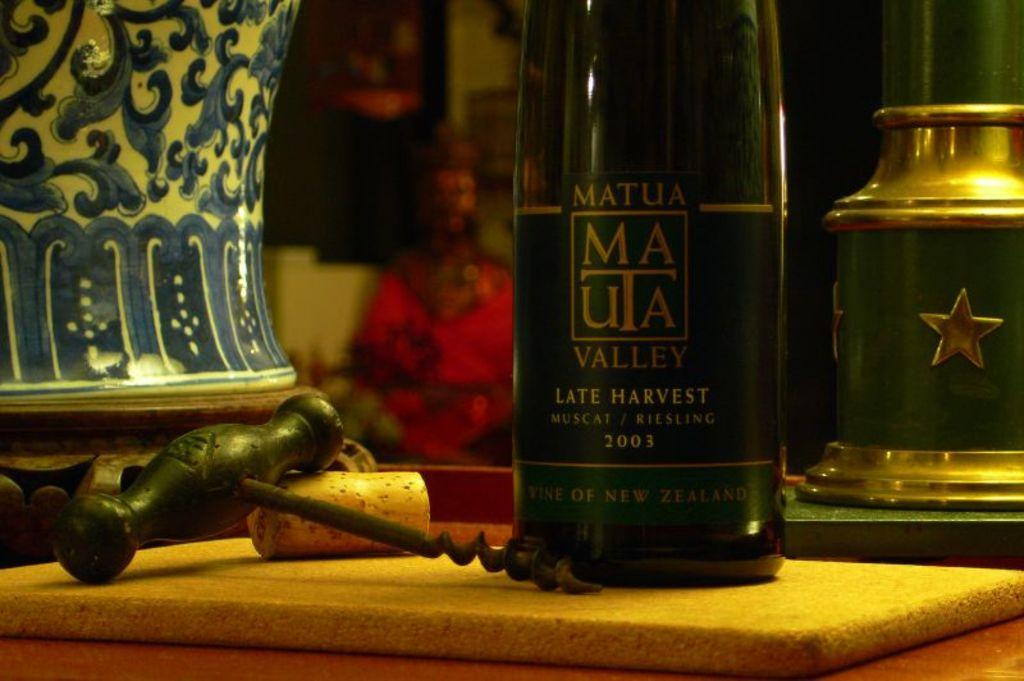<image>
Create a compact narrative representing the image presented. A bottle of Matua Valley from New Zealand sits next to a corkscrew. 